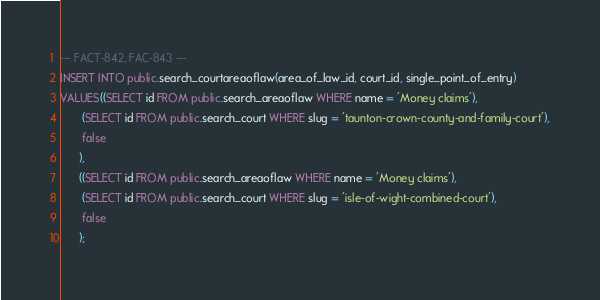<code> <loc_0><loc_0><loc_500><loc_500><_SQL_>--- FACT-842, FAC-843 ---
INSERT INTO public.search_courtareaoflaw(area_of_law_id, court_id, single_point_of_entry)
VALUES((SELECT id FROM public.search_areaoflaw WHERE name = 'Money claims'),
       (SELECT id FROM public.search_court WHERE slug = 'taunton-crown-county-and-family-court'),
       false
      ),
      ((SELECT id FROM public.search_areaoflaw WHERE name = 'Money claims'),
       (SELECT id FROM public.search_court WHERE slug = 'isle-of-wight-combined-court'),
       false
      );
</code> 